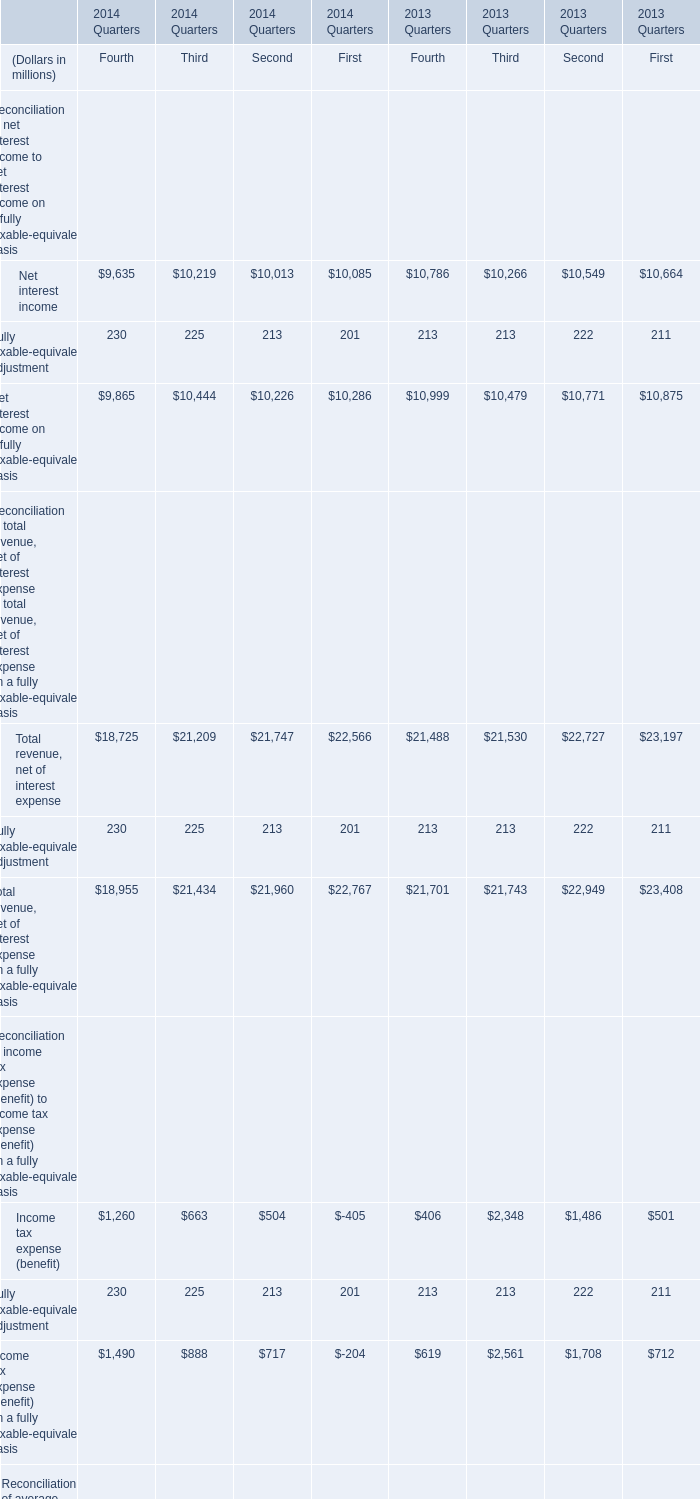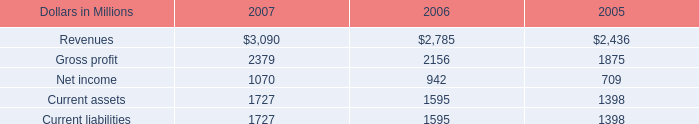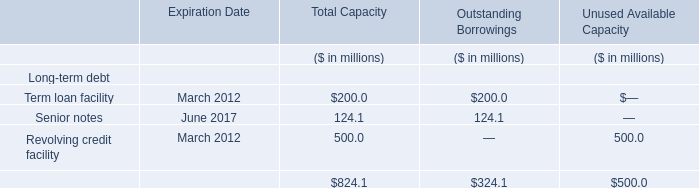What's the sum of Gross profit of 2005, and Net interest income of 2014 Quarters Third ? 
Computations: (1875.0 + 10219.0)
Answer: 12094.0. 